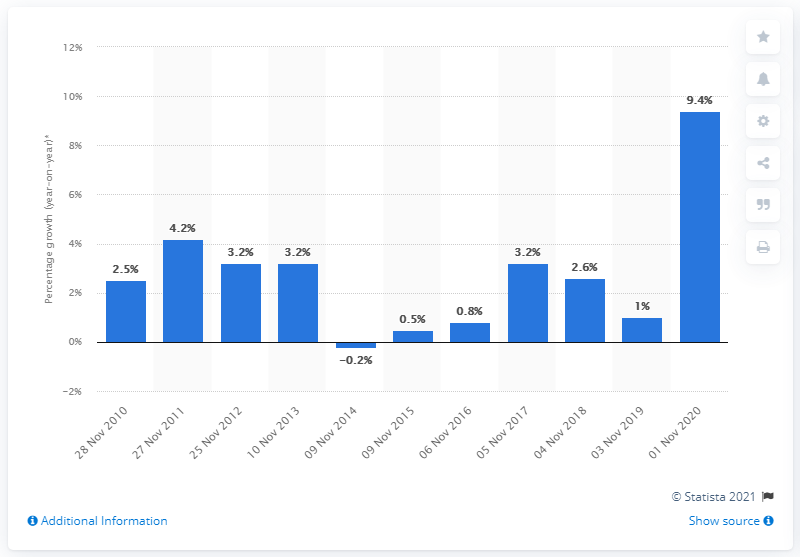Give some essential details in this illustration. The grocery market in Great Britain grew by 9.4% in the three months leading up to November 1, 2020. 